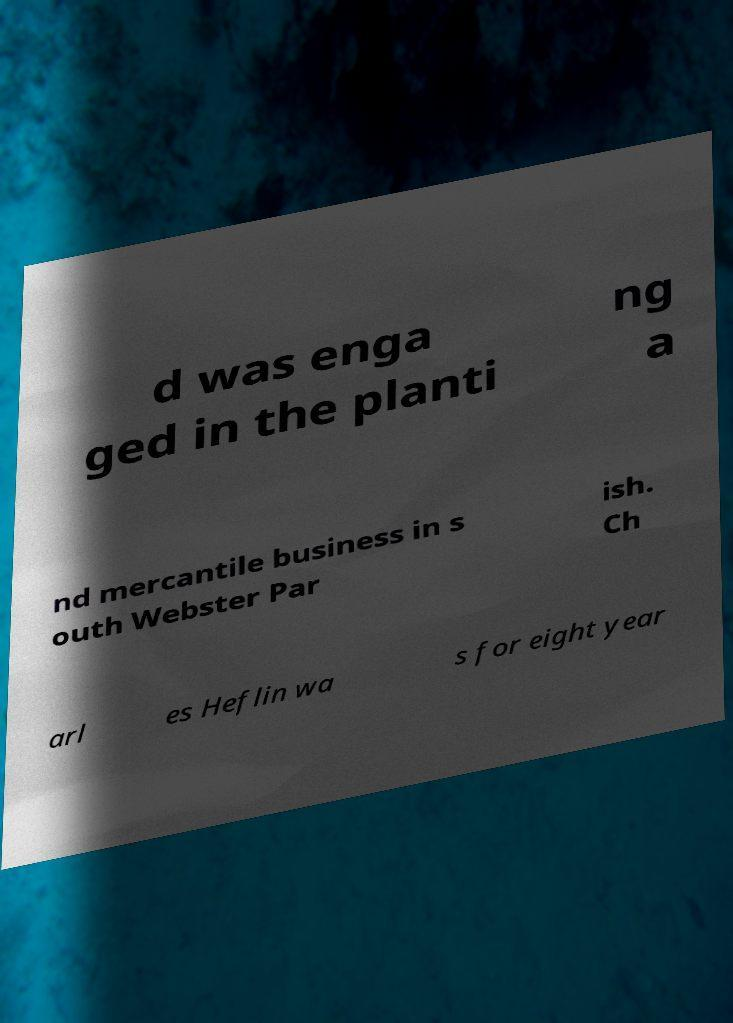There's text embedded in this image that I need extracted. Can you transcribe it verbatim? d was enga ged in the planti ng a nd mercantile business in s outh Webster Par ish. Ch arl es Heflin wa s for eight year 